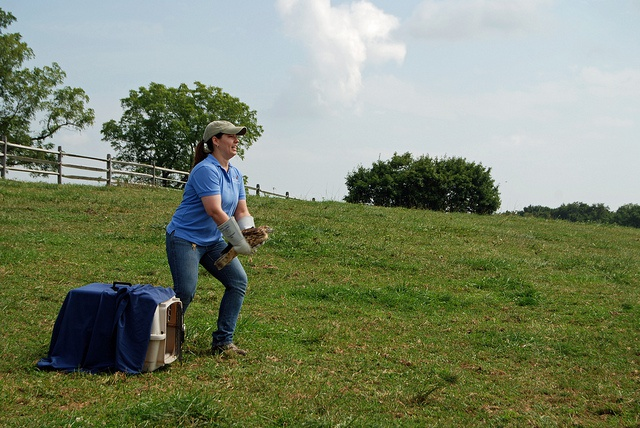Describe the objects in this image and their specific colors. I can see people in lightblue, black, navy, gray, and blue tones and bird in lightblue, olive, black, maroon, and gray tones in this image. 